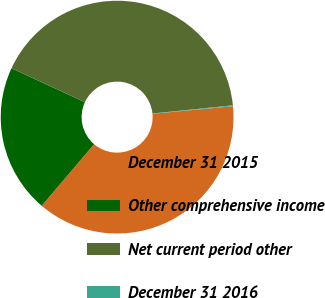Convert chart. <chart><loc_0><loc_0><loc_500><loc_500><pie_chart><fcel>December 31 2015<fcel>Other comprehensive income<fcel>Net current period other<fcel>December 31 2016<nl><fcel>37.71%<fcel>20.68%<fcel>41.48%<fcel>0.12%<nl></chart> 